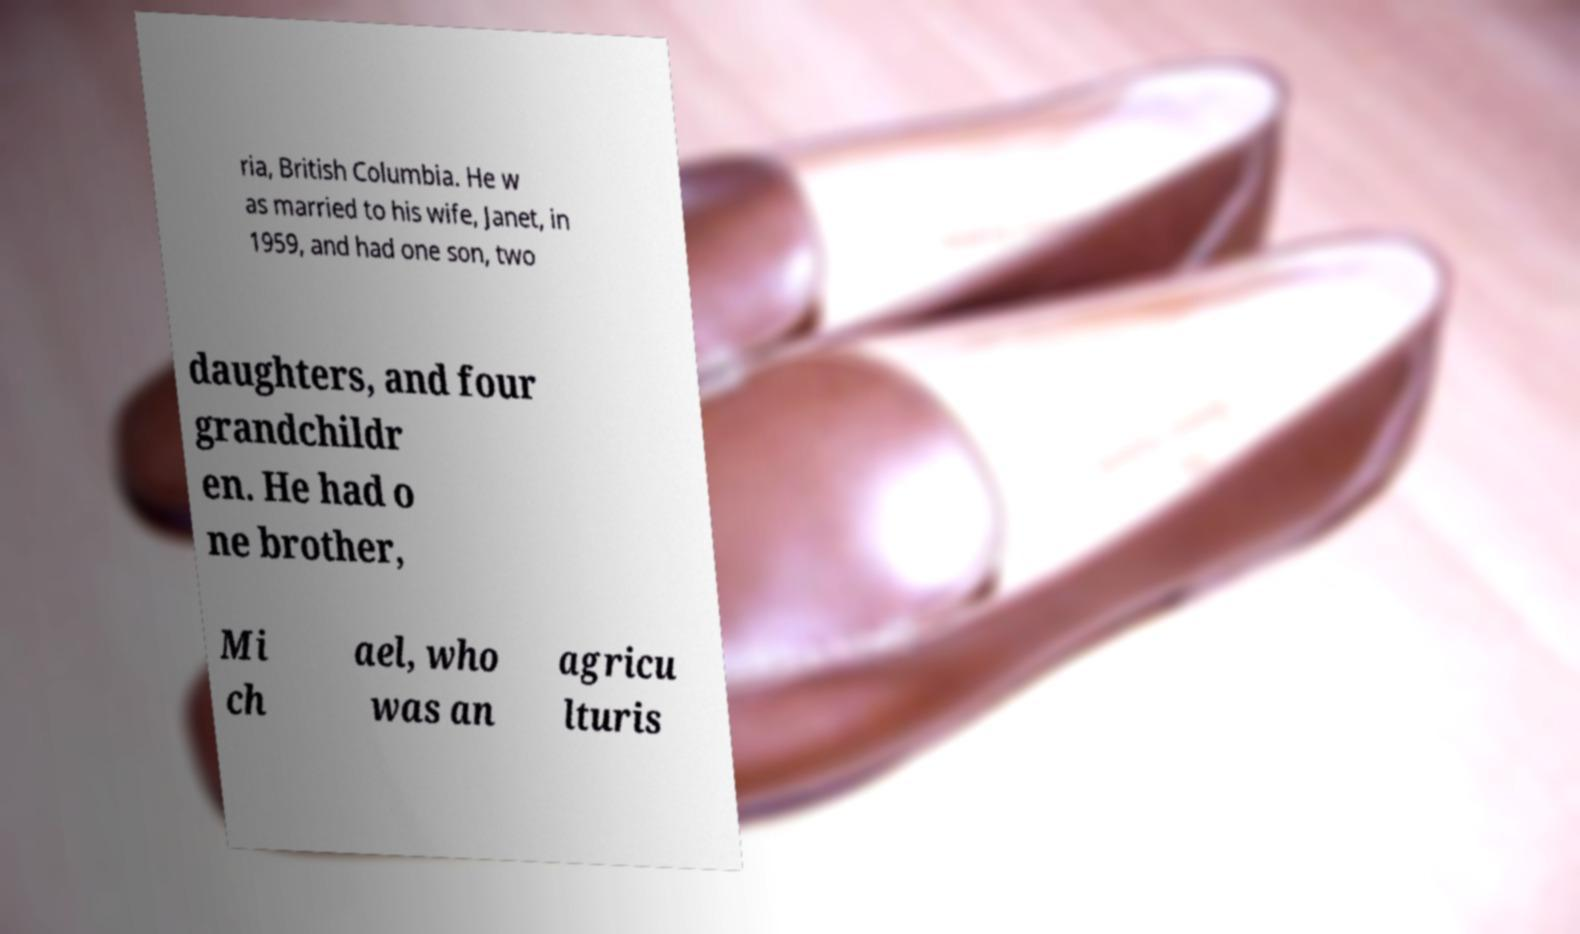Could you extract and type out the text from this image? ria, British Columbia. He w as married to his wife, Janet, in 1959, and had one son, two daughters, and four grandchildr en. He had o ne brother, Mi ch ael, who was an agricu lturis 